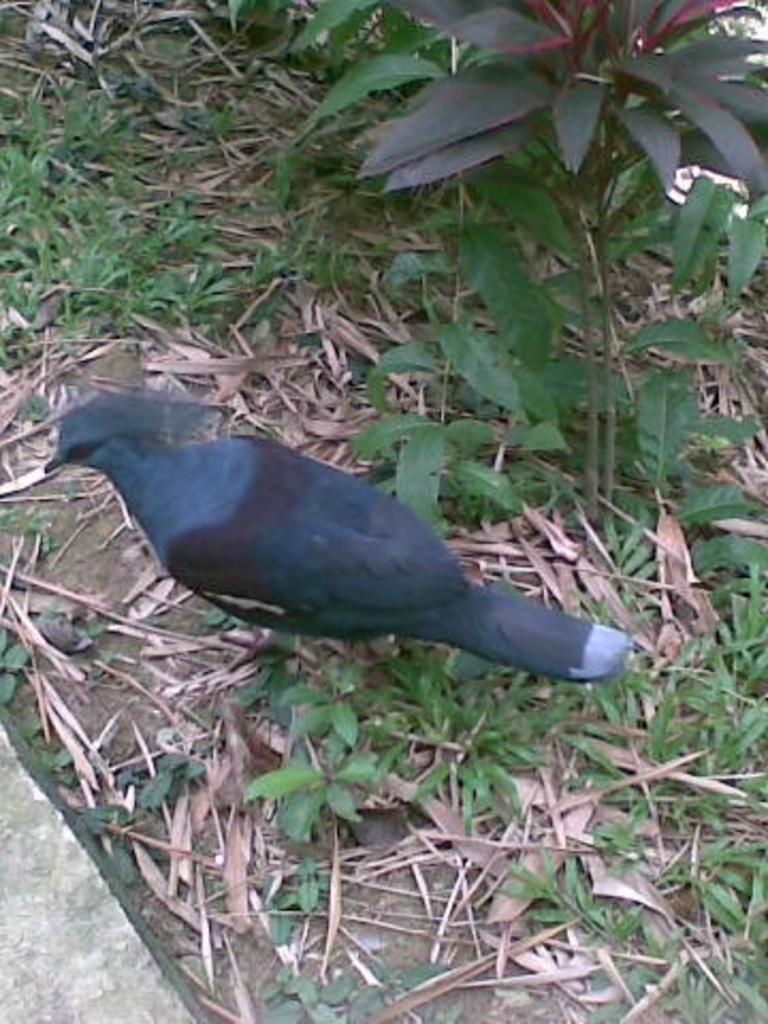Please provide a concise description of this image. In the middle of this image there is a black color bird on the ground. Along with the bird, I can see few plans and dry leaves. 